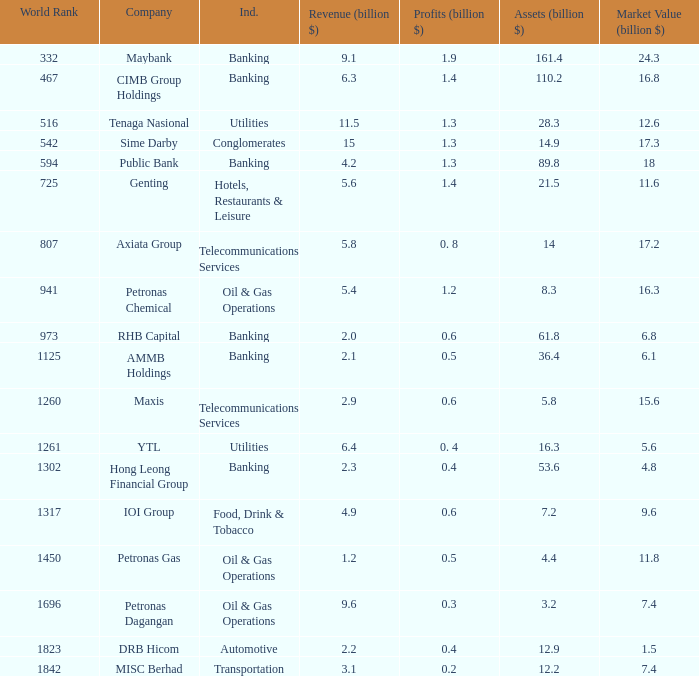Name the profits for market value of 11.8 0.5. 